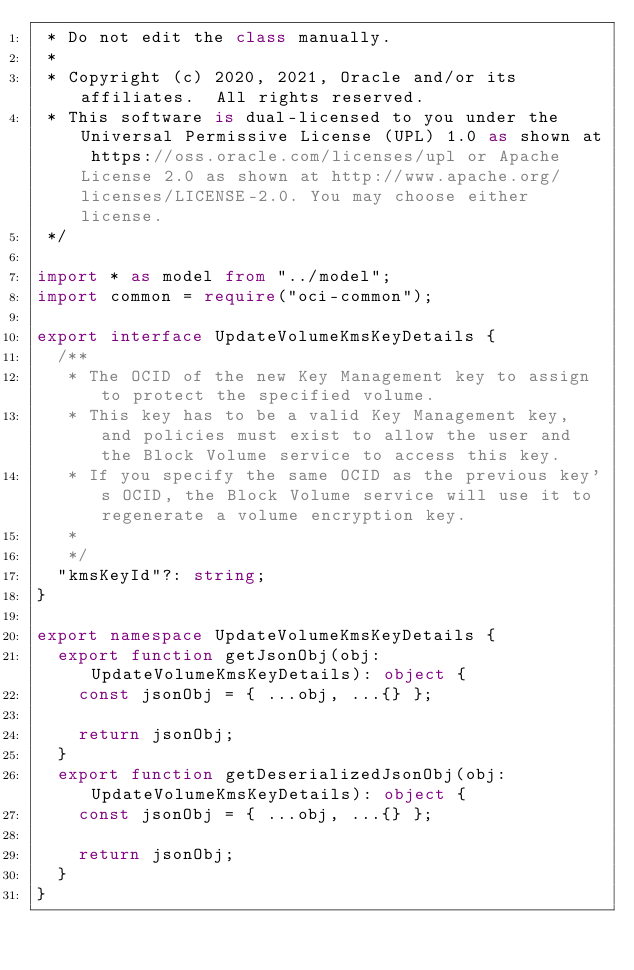Convert code to text. <code><loc_0><loc_0><loc_500><loc_500><_TypeScript_> * Do not edit the class manually.
 *
 * Copyright (c) 2020, 2021, Oracle and/or its affiliates.  All rights reserved.
 * This software is dual-licensed to you under the Universal Permissive License (UPL) 1.0 as shown at https://oss.oracle.com/licenses/upl or Apache License 2.0 as shown at http://www.apache.org/licenses/LICENSE-2.0. You may choose either license.
 */

import * as model from "../model";
import common = require("oci-common");

export interface UpdateVolumeKmsKeyDetails {
  /**
   * The OCID of the new Key Management key to assign to protect the specified volume.
   * This key has to be a valid Key Management key, and policies must exist to allow the user and the Block Volume service to access this key.
   * If you specify the same OCID as the previous key's OCID, the Block Volume service will use it to regenerate a volume encryption key.
   *
   */
  "kmsKeyId"?: string;
}

export namespace UpdateVolumeKmsKeyDetails {
  export function getJsonObj(obj: UpdateVolumeKmsKeyDetails): object {
    const jsonObj = { ...obj, ...{} };

    return jsonObj;
  }
  export function getDeserializedJsonObj(obj: UpdateVolumeKmsKeyDetails): object {
    const jsonObj = { ...obj, ...{} };

    return jsonObj;
  }
}
</code> 